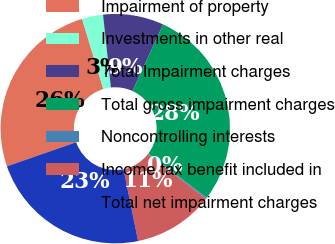Convert chart. <chart><loc_0><loc_0><loc_500><loc_500><pie_chart><fcel>Impairment of property<fcel>Investments in other real<fcel>Total Impairment charges<fcel>Total gross impairment charges<fcel>Noncontrolling interests<fcel>Income tax benefit included in<fcel>Total net impairment charges<nl><fcel>25.65%<fcel>2.97%<fcel>8.55%<fcel>28.44%<fcel>0.19%<fcel>11.33%<fcel>22.87%<nl></chart> 